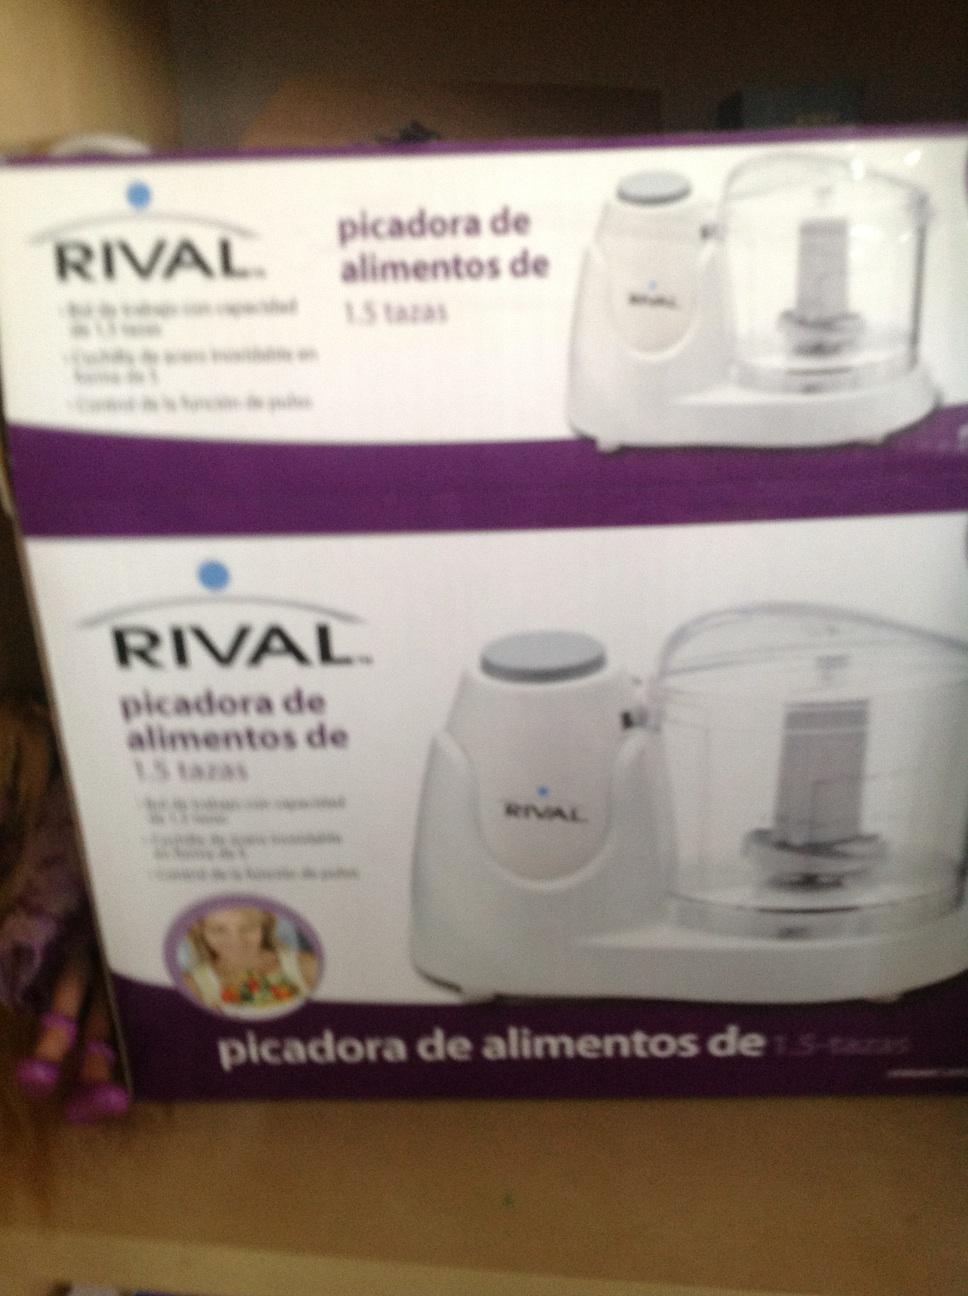Can you describe the product shown in the image? The image shows a product packaged in a box. It is a RIVAL brand food chopper with a capacity of 1.5 cups. It is a kitchen appliance designed to chop and perhaps blend small quantities of food. 